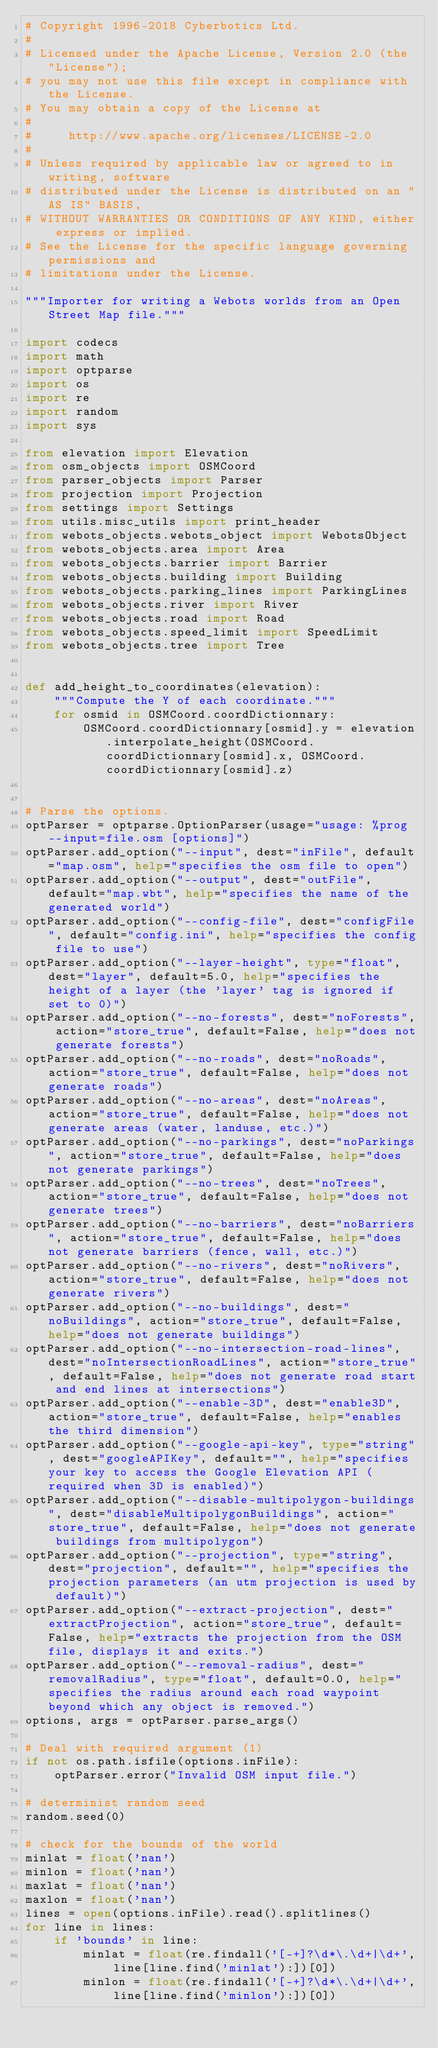Convert code to text. <code><loc_0><loc_0><loc_500><loc_500><_Python_># Copyright 1996-2018 Cyberbotics Ltd.
#
# Licensed under the Apache License, Version 2.0 (the "License");
# you may not use this file except in compliance with the License.
# You may obtain a copy of the License at
#
#     http://www.apache.org/licenses/LICENSE-2.0
#
# Unless required by applicable law or agreed to in writing, software
# distributed under the License is distributed on an "AS IS" BASIS,
# WITHOUT WARRANTIES OR CONDITIONS OF ANY KIND, either express or implied.
# See the License for the specific language governing permissions and
# limitations under the License.

"""Importer for writing a Webots worlds from an Open Street Map file."""

import codecs
import math
import optparse
import os
import re
import random
import sys

from elevation import Elevation
from osm_objects import OSMCoord
from parser_objects import Parser
from projection import Projection
from settings import Settings
from utils.misc_utils import print_header
from webots_objects.webots_object import WebotsObject
from webots_objects.area import Area
from webots_objects.barrier import Barrier
from webots_objects.building import Building
from webots_objects.parking_lines import ParkingLines
from webots_objects.river import River
from webots_objects.road import Road
from webots_objects.speed_limit import SpeedLimit
from webots_objects.tree import Tree


def add_height_to_coordinates(elevation):
    """Compute the Y of each coordinate."""
    for osmid in OSMCoord.coordDictionnary:
        OSMCoord.coordDictionnary[osmid].y = elevation.interpolate_height(OSMCoord.coordDictionnary[osmid].x, OSMCoord.coordDictionnary[osmid].z)


# Parse the options.
optParser = optparse.OptionParser(usage="usage: %prog --input=file.osm [options]")
optParser.add_option("--input", dest="inFile", default="map.osm", help="specifies the osm file to open")
optParser.add_option("--output", dest="outFile", default="map.wbt", help="specifies the name of the generated world")
optParser.add_option("--config-file", dest="configFile", default="config.ini", help="specifies the config file to use")
optParser.add_option("--layer-height", type="float", dest="layer", default=5.0, help="specifies the height of a layer (the 'layer' tag is ignored if set to 0)")
optParser.add_option("--no-forests", dest="noForests", action="store_true", default=False, help="does not generate forests")
optParser.add_option("--no-roads", dest="noRoads", action="store_true", default=False, help="does not generate roads")
optParser.add_option("--no-areas", dest="noAreas", action="store_true", default=False, help="does not generate areas (water, landuse, etc.)")
optParser.add_option("--no-parkings", dest="noParkings", action="store_true", default=False, help="does not generate parkings")
optParser.add_option("--no-trees", dest="noTrees", action="store_true", default=False, help="does not generate trees")
optParser.add_option("--no-barriers", dest="noBarriers", action="store_true", default=False, help="does not generate barriers (fence, wall, etc.)")
optParser.add_option("--no-rivers", dest="noRivers", action="store_true", default=False, help="does not generate rivers")
optParser.add_option("--no-buildings", dest="noBuildings", action="store_true", default=False, help="does not generate buildings")
optParser.add_option("--no-intersection-road-lines", dest="noIntersectionRoadLines", action="store_true", default=False, help="does not generate road start and end lines at intersections")
optParser.add_option("--enable-3D", dest="enable3D", action="store_true", default=False, help="enables the third dimension")
optParser.add_option("--google-api-key", type="string", dest="googleAPIKey", default="", help="specifies your key to access the Google Elevation API (required when 3D is enabled)")
optParser.add_option("--disable-multipolygon-buildings", dest="disableMultipolygonBuildings", action="store_true", default=False, help="does not generate buildings from multipolygon")
optParser.add_option("--projection", type="string", dest="projection", default="", help="specifies the projection parameters (an utm projection is used by default)")
optParser.add_option("--extract-projection", dest="extractProjection", action="store_true", default=False, help="extracts the projection from the OSM file, displays it and exits.")
optParser.add_option("--removal-radius", dest="removalRadius", type="float", default=0.0, help="specifies the radius around each road waypoint beyond which any object is removed.")
options, args = optParser.parse_args()

# Deal with required argument (1)
if not os.path.isfile(options.inFile):
    optParser.error("Invalid OSM input file.")

# determinist random seed
random.seed(0)

# check for the bounds of the world
minlat = float('nan')
minlon = float('nan')
maxlat = float('nan')
maxlon = float('nan')
lines = open(options.inFile).read().splitlines()
for line in lines:
    if 'bounds' in line:
        minlat = float(re.findall('[-+]?\d*\.\d+|\d+', line[line.find('minlat'):])[0])
        minlon = float(re.findall('[-+]?\d*\.\d+|\d+', line[line.find('minlon'):])[0])</code> 